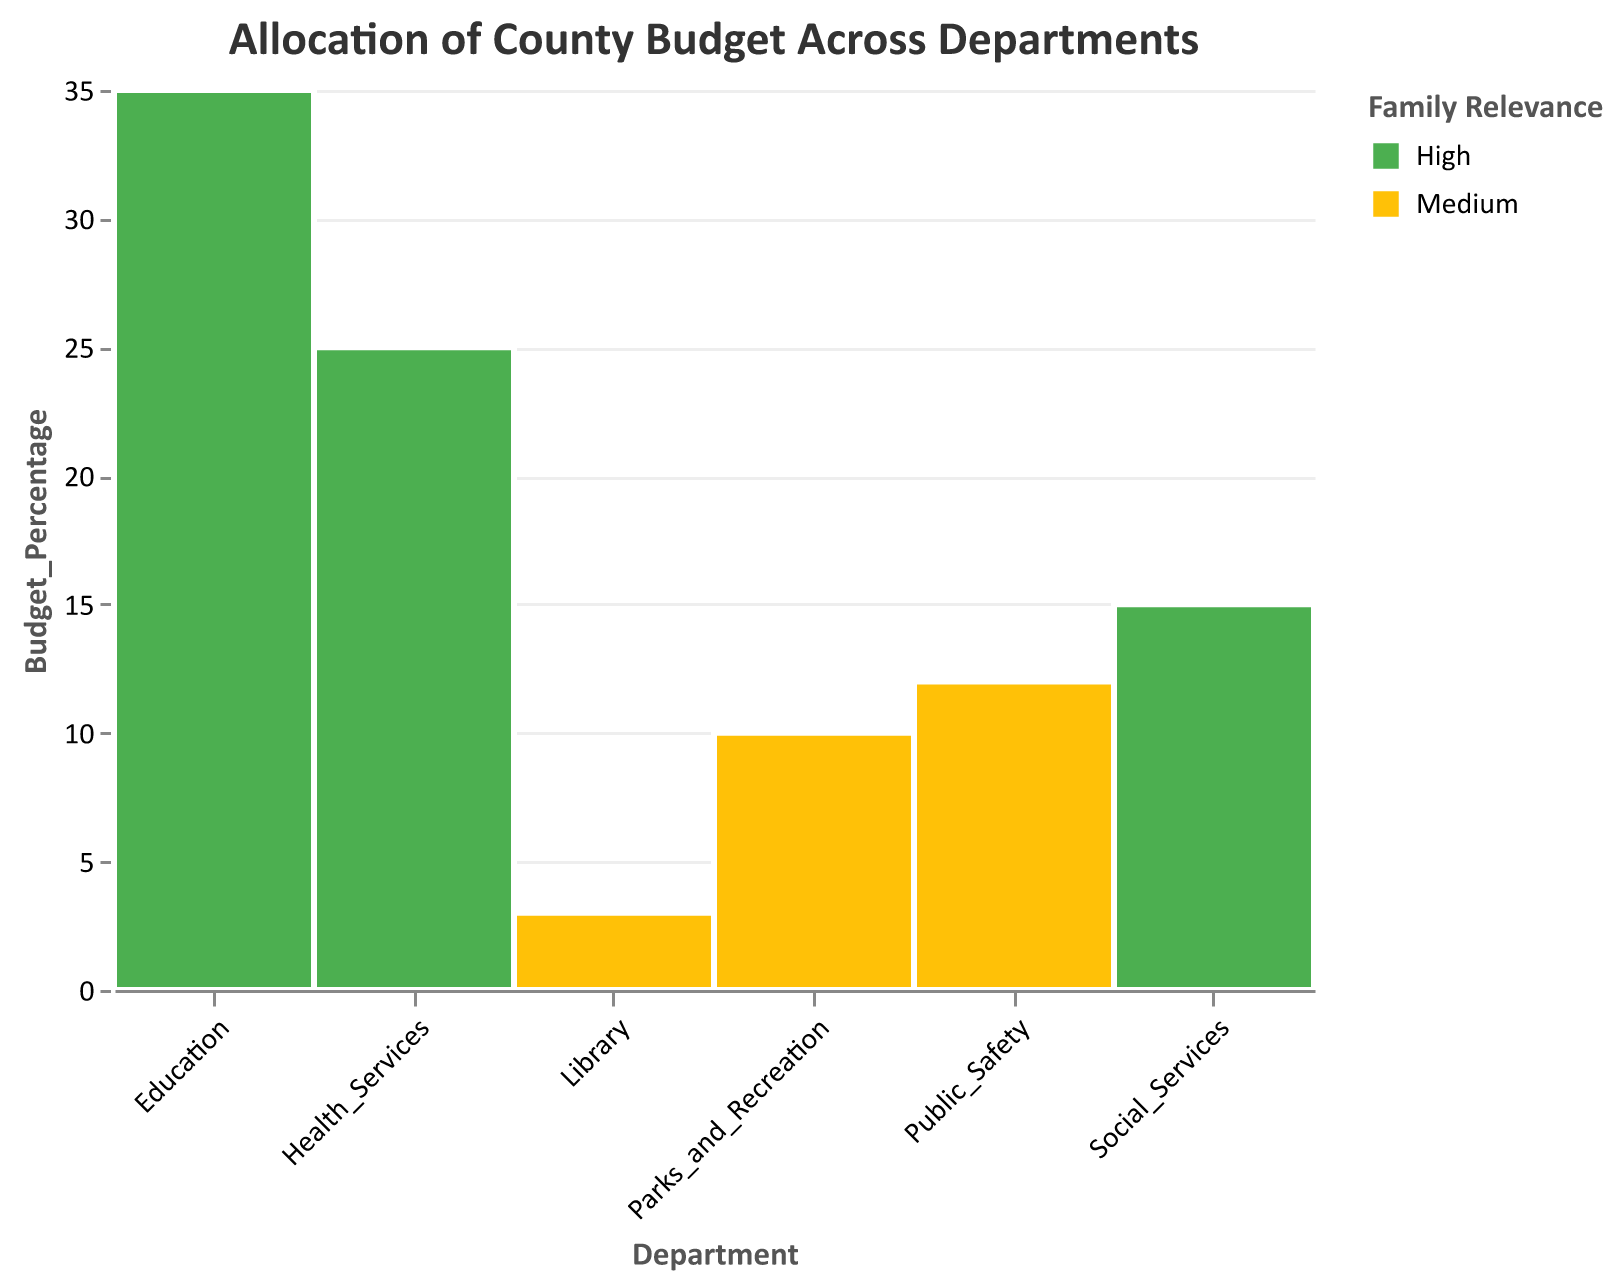Which department receives the highest percentage of the county budget? The plot shows the budgets as rectangles, with the largest one representing the highest budget allocation. The Education department has the largest rectangle.
Answer: Education What is the percentage of the budget allocated to Health Services? Looking at the y-axis and the height of the Health Services rectangle, we see that it corresponds to 25%.
Answer: 25% How many departments have a high relevance to families? The legend for 'Family Relevance' shows 'High' in green. There are three green rectangles: Education, Health Services, and Social Services.
Answer: 3 What is the total percentage of the budget allocated to departments with medium family relevance? Medium relevance departments are Parks and Recreation, Public Safety, and Library. Adding their percentages: 10% + 12% + 3% = 25%.
Answer: 25% Which department has the smallest budget allocation, and what is its family relevance? The smallest rectangle corresponds to the Library department. According to the color coding, the Library has medium family relevance.
Answer: Library; Medium What is the difference in budget allocation between Social Services and Public Safety? Social Services has 15% and Public Safety has 12%. The difference is 15% - 12% = 3%.
Answer: 3% How much higher is the budget percentage for Education compared to Parks and Recreation? Education has 35% and Parks and Recreation has 10%. The difference is 35% - 10% = 25%.
Answer: 25% Which department with high family relevance receives the least budget allocation? Among the departments marked high in family relevance (green), Social Services has the lowest at 15%.
Answer: Social Services What is the combined budget percentage for departments related to social services and health services? Health Services has 25% and Social Services has 15%. Their combined budget is 25% + 15% = 40%.
Answer: 40% 